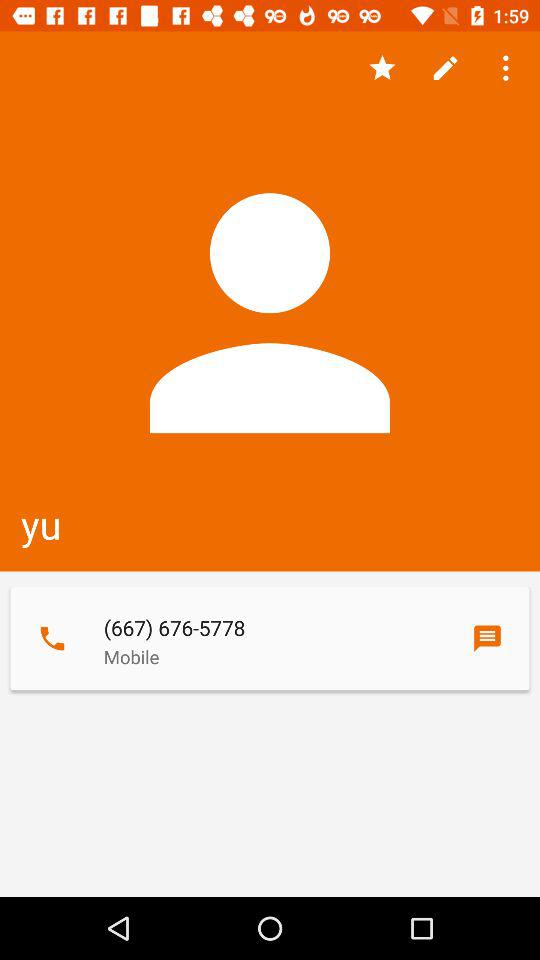What is the user name? The user name is Yu. 